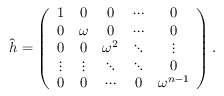<formula> <loc_0><loc_0><loc_500><loc_500>\hat { h } = \left ( \begin{array} { c c c c c } { 1 } & { 0 } & { 0 } & { \cdots } & { 0 } \\ { 0 } & { \omega } & { 0 } & { \cdots } & { 0 } \\ { 0 } & { 0 } & { { \omega ^ { 2 } } } & { \ddots } & { \vdots } \\ { \vdots } & { \vdots } & { \ddots } & { \ddots } & { 0 } \\ { 0 } & { 0 } & { \cdots } & { 0 } & { { \omega ^ { n - 1 } } } \end{array} \right ) .</formula> 